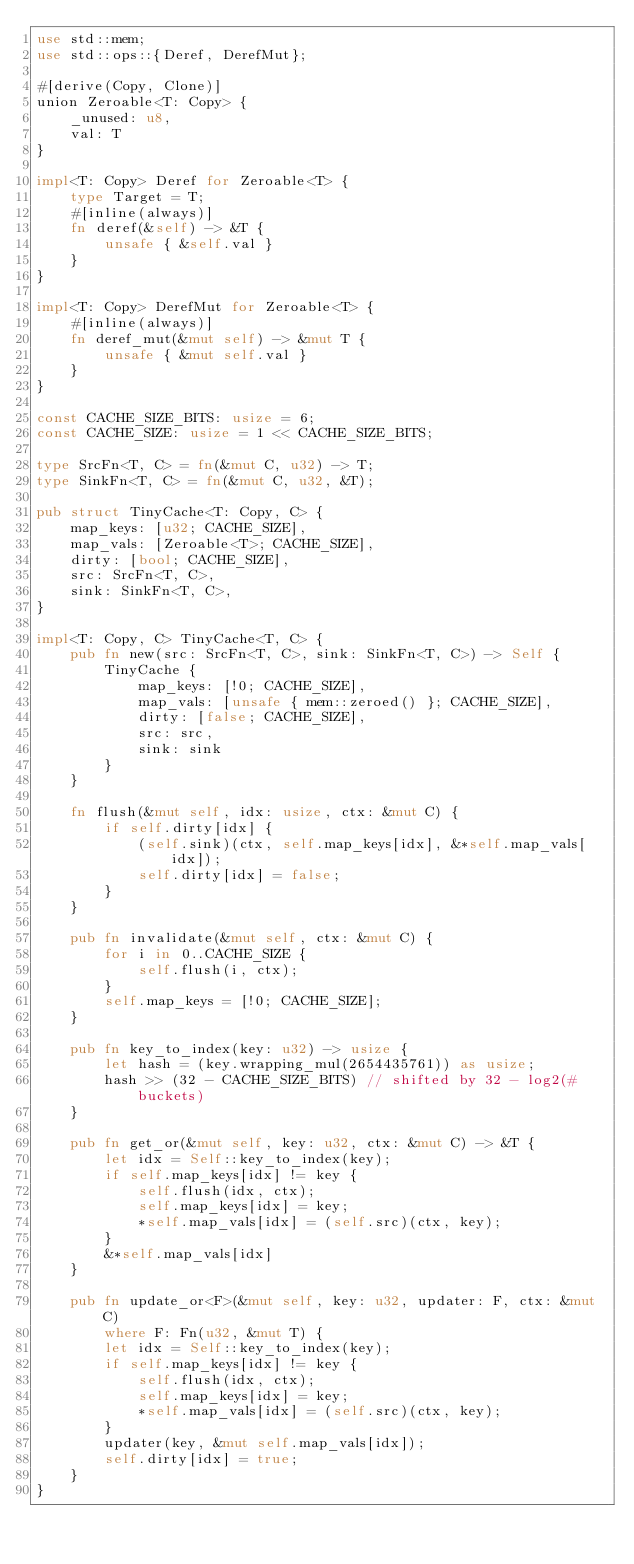<code> <loc_0><loc_0><loc_500><loc_500><_Rust_>use std::mem;
use std::ops::{Deref, DerefMut};

#[derive(Copy, Clone)]
union Zeroable<T: Copy> {
    _unused: u8,
    val: T
}

impl<T: Copy> Deref for Zeroable<T> {
    type Target = T;
    #[inline(always)]
    fn deref(&self) -> &T {
        unsafe { &self.val }
    }
}

impl<T: Copy> DerefMut for Zeroable<T> {
    #[inline(always)]
    fn deref_mut(&mut self) -> &mut T {
        unsafe { &mut self.val }
    }
}

const CACHE_SIZE_BITS: usize = 6;
const CACHE_SIZE: usize = 1 << CACHE_SIZE_BITS;

type SrcFn<T, C> = fn(&mut C, u32) -> T;
type SinkFn<T, C> = fn(&mut C, u32, &T);

pub struct TinyCache<T: Copy, C> {
    map_keys: [u32; CACHE_SIZE],
    map_vals: [Zeroable<T>; CACHE_SIZE],
    dirty: [bool; CACHE_SIZE],
    src: SrcFn<T, C>,
    sink: SinkFn<T, C>,
}

impl<T: Copy, C> TinyCache<T, C> {
    pub fn new(src: SrcFn<T, C>, sink: SinkFn<T, C>) -> Self {
        TinyCache {
            map_keys: [!0; CACHE_SIZE],
            map_vals: [unsafe { mem::zeroed() }; CACHE_SIZE],
            dirty: [false; CACHE_SIZE],
            src: src,
            sink: sink
        }
    }

    fn flush(&mut self, idx: usize, ctx: &mut C) {
        if self.dirty[idx] {
            (self.sink)(ctx, self.map_keys[idx], &*self.map_vals[idx]);
            self.dirty[idx] = false;
        }
    }

    pub fn invalidate(&mut self, ctx: &mut C) {
        for i in 0..CACHE_SIZE {
            self.flush(i, ctx);
        }
        self.map_keys = [!0; CACHE_SIZE];
    }

    pub fn key_to_index(key: u32) -> usize {
        let hash = (key.wrapping_mul(2654435761)) as usize;
        hash >> (32 - CACHE_SIZE_BITS) // shifted by 32 - log2(# buckets)
    }

    pub fn get_or(&mut self, key: u32, ctx: &mut C) -> &T {
        let idx = Self::key_to_index(key);
        if self.map_keys[idx] != key {
            self.flush(idx, ctx);
            self.map_keys[idx] = key;
            *self.map_vals[idx] = (self.src)(ctx, key);
        }
        &*self.map_vals[idx]
    }

    pub fn update_or<F>(&mut self, key: u32, updater: F, ctx: &mut C)
        where F: Fn(u32, &mut T) {
        let idx = Self::key_to_index(key);
        if self.map_keys[idx] != key {
            self.flush(idx, ctx);
            self.map_keys[idx] = key;
            *self.map_vals[idx] = (self.src)(ctx, key);
        }
        updater(key, &mut self.map_vals[idx]);
        self.dirty[idx] = true;
    }
}
</code> 